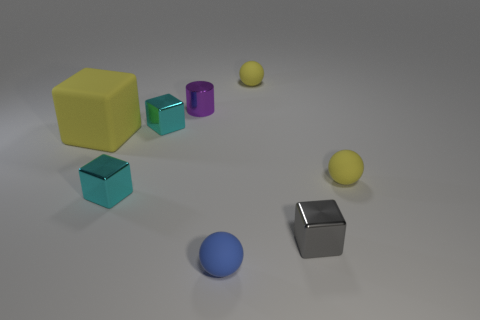The tiny yellow thing that is on the left side of the shiny thing on the right side of the small purple thing is made of what material?
Your answer should be compact. Rubber. Are there any large cyan shiny objects that have the same shape as the big yellow rubber thing?
Make the answer very short. No. What color is the cylinder that is the same size as the blue matte object?
Offer a very short reply. Purple. What number of objects are either objects that are behind the big cube or blocks that are on the left side of the small gray shiny object?
Keep it short and to the point. 5. What number of objects are either metallic cubes or shiny things?
Provide a short and direct response. 4. There is a matte object that is both to the right of the blue rubber thing and in front of the big object; how big is it?
Provide a short and direct response. Small. What number of big blocks are made of the same material as the cylinder?
Make the answer very short. 0. There is a block that is made of the same material as the small blue object; what is its color?
Provide a short and direct response. Yellow. Is the color of the block that is behind the large rubber cube the same as the metallic cylinder?
Keep it short and to the point. No. What is the ball behind the purple metallic object made of?
Your answer should be very brief. Rubber. 